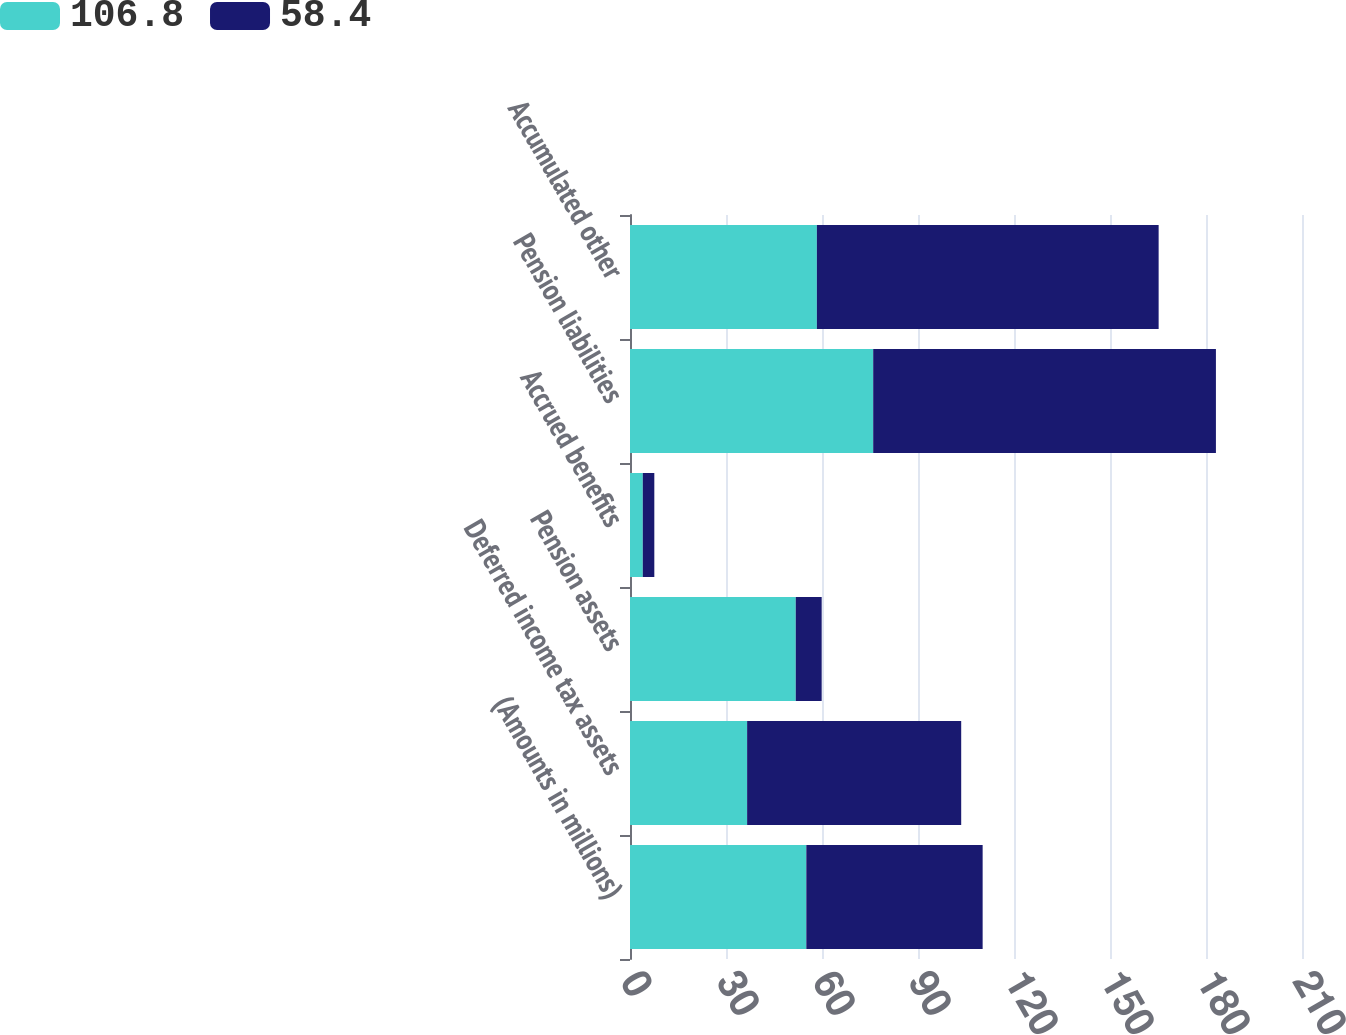<chart> <loc_0><loc_0><loc_500><loc_500><stacked_bar_chart><ecel><fcel>(Amounts in millions)<fcel>Deferred income tax assets<fcel>Pension assets<fcel>Accrued benefits<fcel>Pension liabilities<fcel>Accumulated other<nl><fcel>106.8<fcel>55.1<fcel>36.6<fcel>51.8<fcel>4<fcel>76<fcel>58.4<nl><fcel>58.4<fcel>55.1<fcel>66.9<fcel>8.1<fcel>3.6<fcel>107.1<fcel>106.8<nl></chart> 